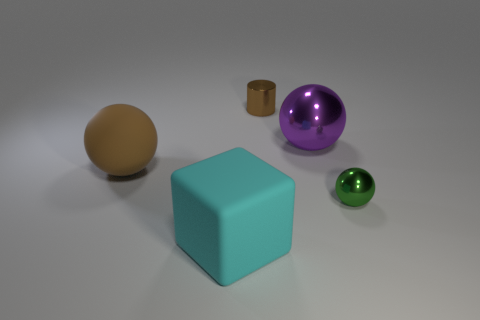Subtract all tiny green balls. How many balls are left? 2 Add 2 cubes. How many objects exist? 7 Subtract all cubes. How many objects are left? 4 Add 5 large brown rubber objects. How many large brown rubber objects exist? 6 Subtract 0 yellow blocks. How many objects are left? 5 Subtract all large red cylinders. Subtract all big shiny things. How many objects are left? 4 Add 5 large metallic spheres. How many large metallic spheres are left? 6 